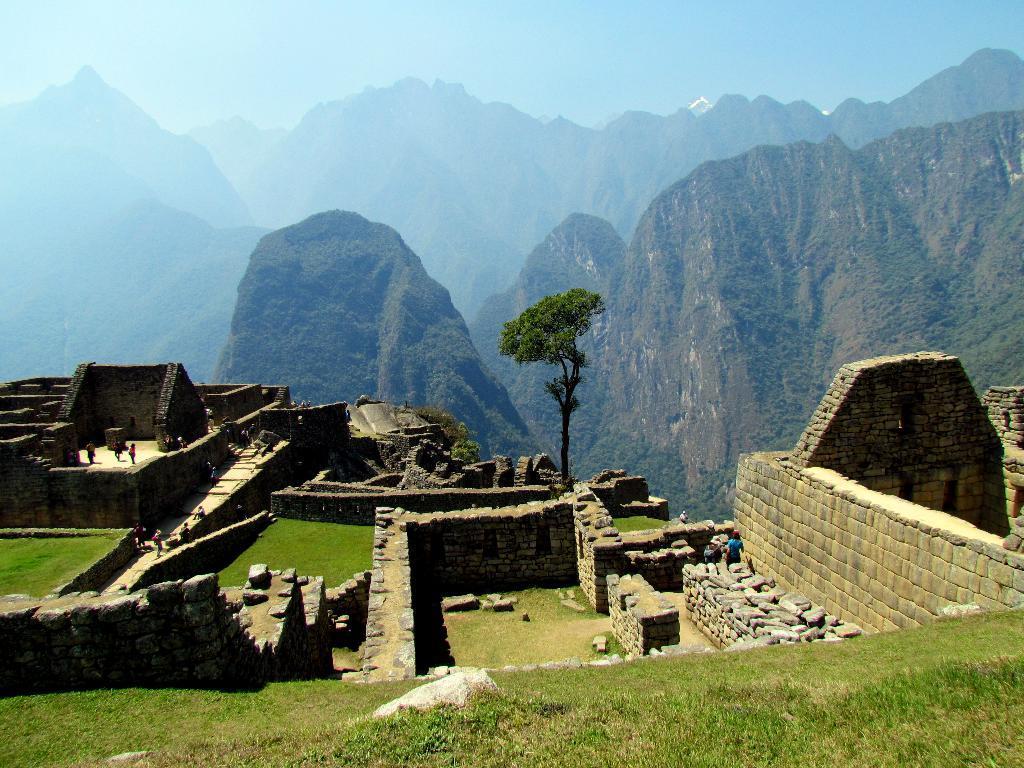Describe this image in one or two sentences. In this image I can see grass in the front and on the both side of this image I can see number of people. In the centre of this image I can see a tree and in the background I can see mountains and the sky. 